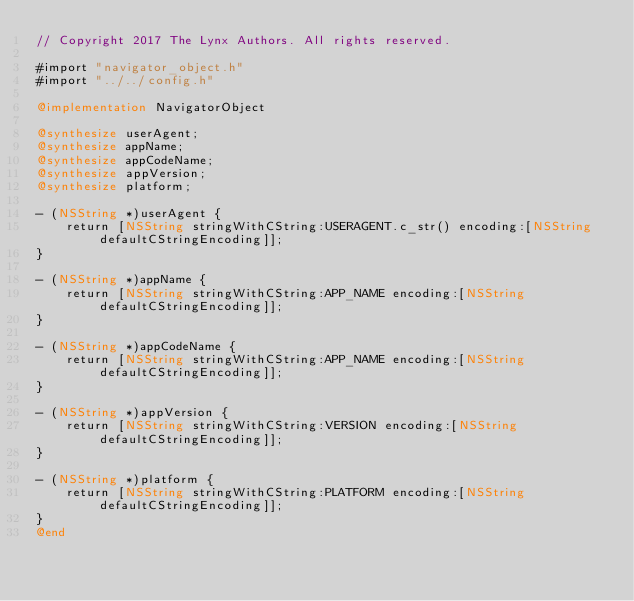Convert code to text. <code><loc_0><loc_0><loc_500><loc_500><_ObjectiveC_>// Copyright 2017 The Lynx Authors. All rights reserved.

#import "navigator_object.h"
#import "../../config.h"

@implementation NavigatorObject

@synthesize userAgent;
@synthesize appName;
@synthesize appCodeName;
@synthesize appVersion;
@synthesize platform;

- (NSString *)userAgent {
    return [NSString stringWithCString:USERAGENT.c_str() encoding:[NSString defaultCStringEncoding]];
}

- (NSString *)appName {
    return [NSString stringWithCString:APP_NAME encoding:[NSString defaultCStringEncoding]];
}

- (NSString *)appCodeName {
    return [NSString stringWithCString:APP_NAME encoding:[NSString defaultCStringEncoding]];
}

- (NSString *)appVersion {
    return [NSString stringWithCString:VERSION encoding:[NSString defaultCStringEncoding]];
}

- (NSString *)platform {
    return [NSString stringWithCString:PLATFORM encoding:[NSString defaultCStringEncoding]];
}
@end
</code> 